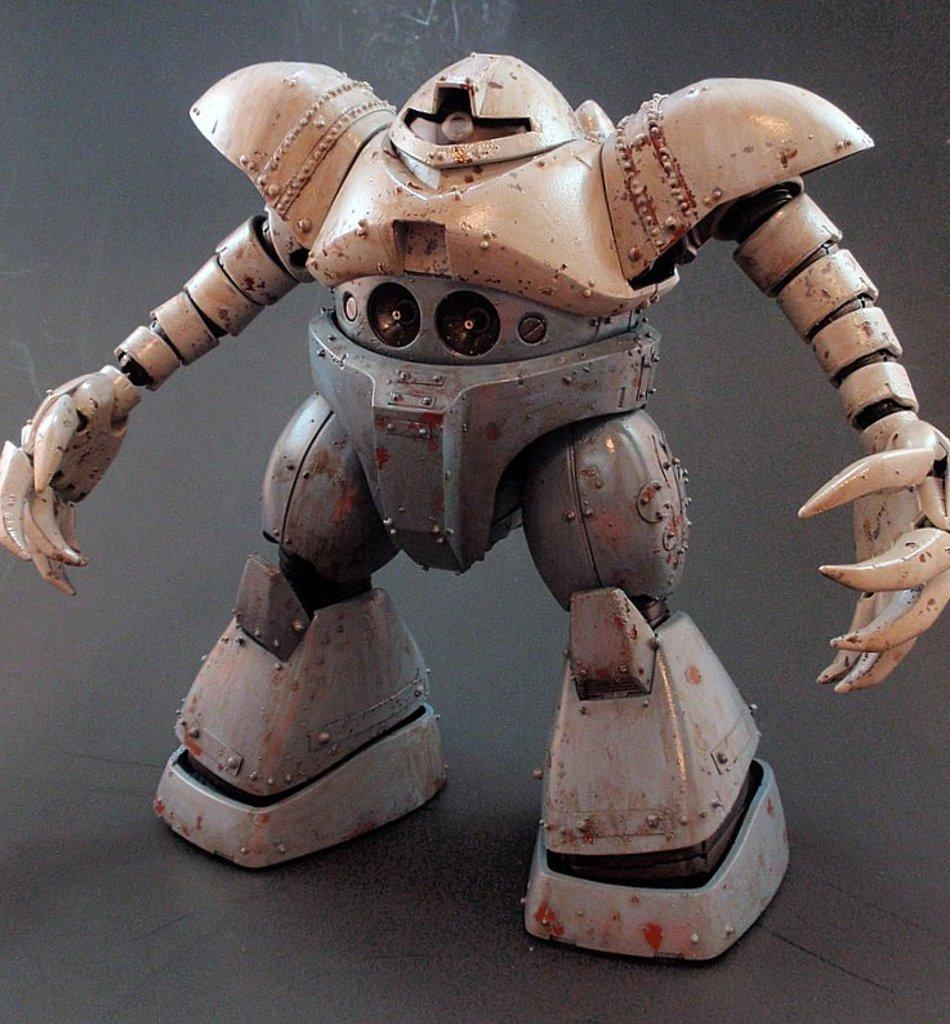What type of toy is in the image? There is a robot toy in the image. Where is the robot toy located? The robot toy is on the floor. What type of shoes is the robot toy wearing in the image? The robot toy is not a living being and therefore does not wear shoes. 